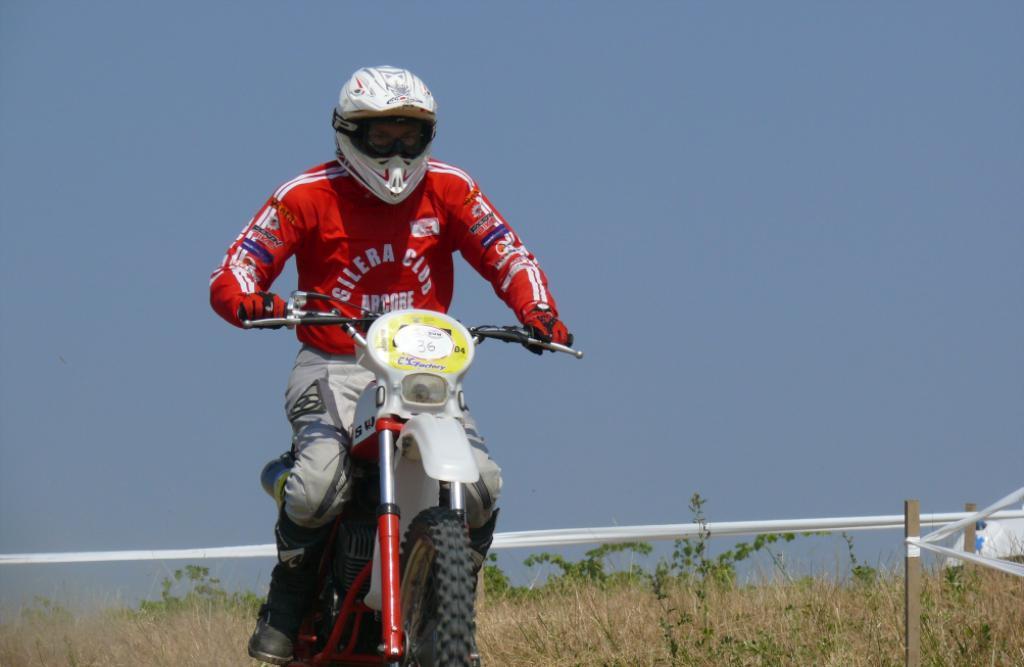Describe this image in one or two sentences. There is a person in red color coat, sitting on a bike and riding it. In the background, there is white color thread, which is attached to the wooden pole. In the background, there are dry plants, plants and there is blue sky. 